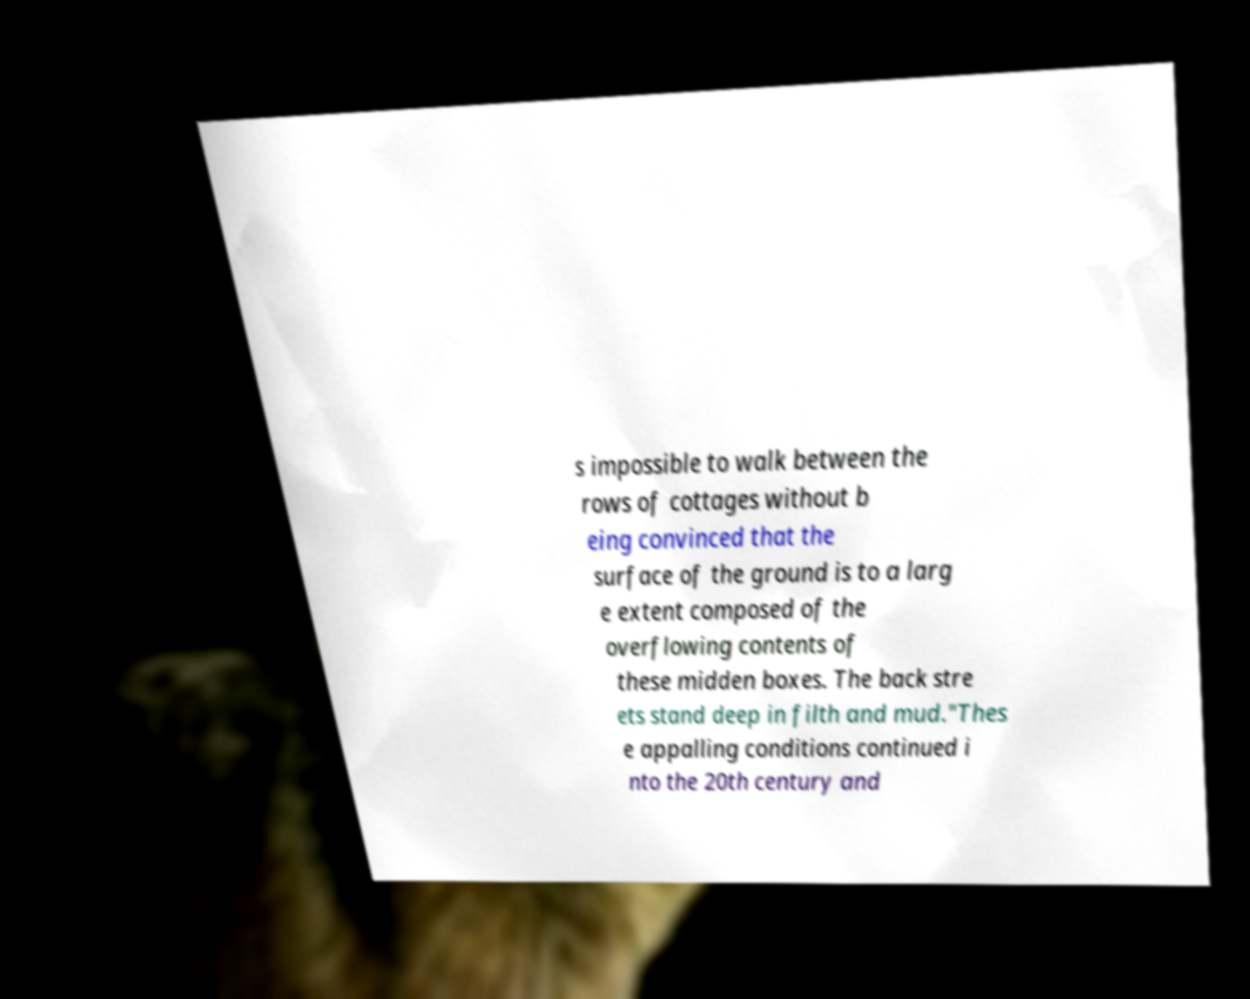Could you extract and type out the text from this image? s impossible to walk between the rows of cottages without b eing convinced that the surface of the ground is to a larg e extent composed of the overflowing contents of these midden boxes. The back stre ets stand deep in filth and mud."Thes e appalling conditions continued i nto the 20th century and 